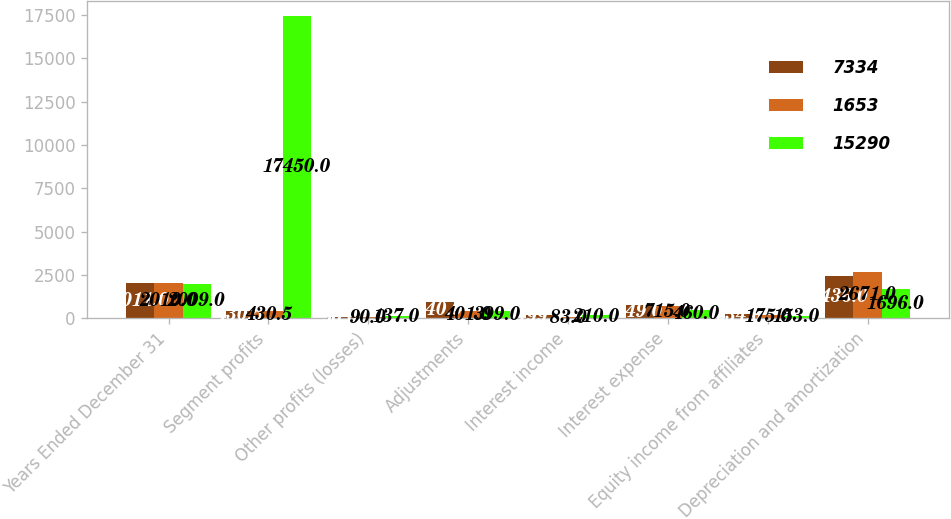<chart> <loc_0><loc_0><loc_500><loc_500><stacked_bar_chart><ecel><fcel>Years Ended December 31<fcel>Segment profits<fcel>Other profits (losses)<fcel>Adjustments<fcel>Interest income<fcel>Interest expense<fcel>Equity income from affiliates<fcel>Depreciation and amortization<nl><fcel>7334<fcel>2011<fcel>430.5<fcel>90<fcel>940<fcel>199<fcel>749<fcel>234<fcel>2436<nl><fcel>1653<fcel>2010<fcel>430.5<fcel>90<fcel>401<fcel>83<fcel>715<fcel>175<fcel>2671<nl><fcel>15290<fcel>2009<fcel>17450<fcel>137<fcel>399<fcel>210<fcel>460<fcel>153<fcel>1696<nl></chart> 